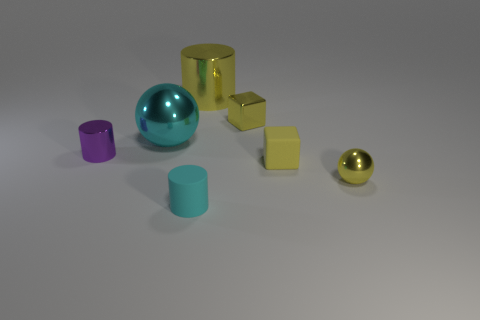Subtract all small cylinders. How many cylinders are left? 1 Add 3 big cylinders. How many objects exist? 10 Subtract all cyan cylinders. How many cylinders are left? 2 Subtract all cylinders. How many objects are left? 4 Subtract 2 cubes. How many cubes are left? 0 Add 2 balls. How many balls exist? 4 Subtract 0 red spheres. How many objects are left? 7 Subtract all blue balls. Subtract all brown cylinders. How many balls are left? 2 Subtract all purple balls. How many yellow cylinders are left? 1 Subtract all blocks. Subtract all matte things. How many objects are left? 3 